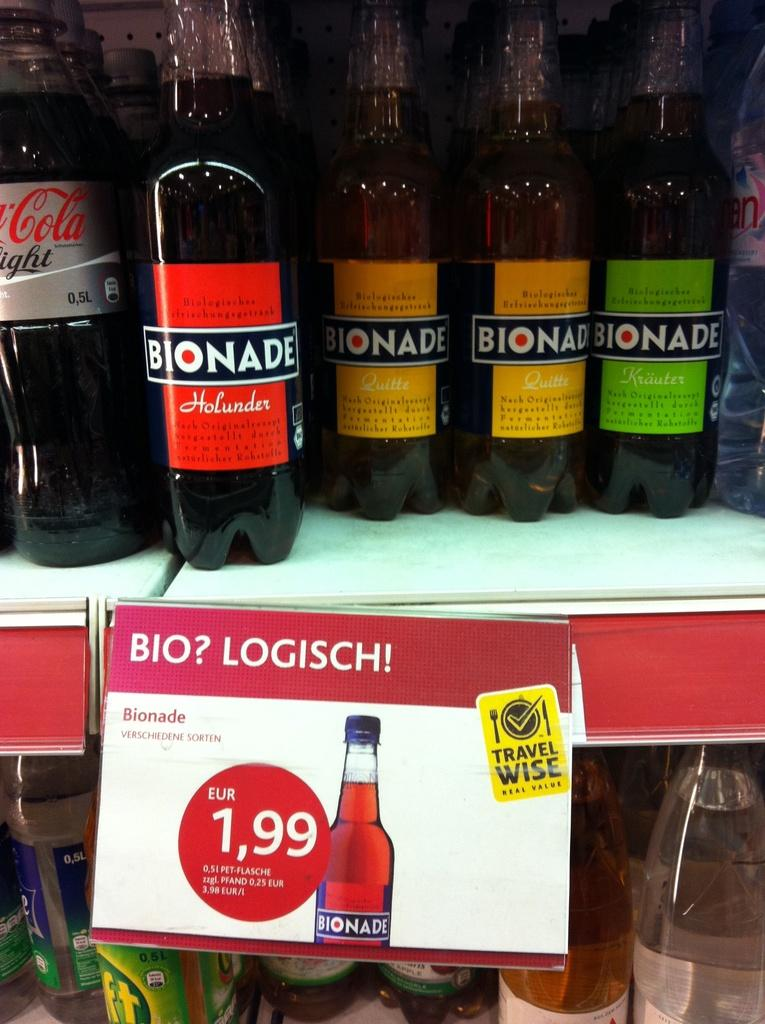<image>
Describe the image concisely. A shelf on different bondade bottles next to a diet coca-cola bottle. 